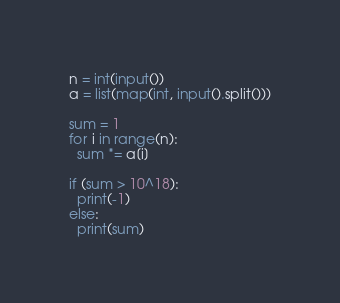Convert code to text. <code><loc_0><loc_0><loc_500><loc_500><_Python_>n = int(input())
a = list(map(int, input().split()))

sum = 1
for i in range(n):
  sum *= a[i]

if (sum > 10^18):
  print(-1)
else:
  print(sum)</code> 